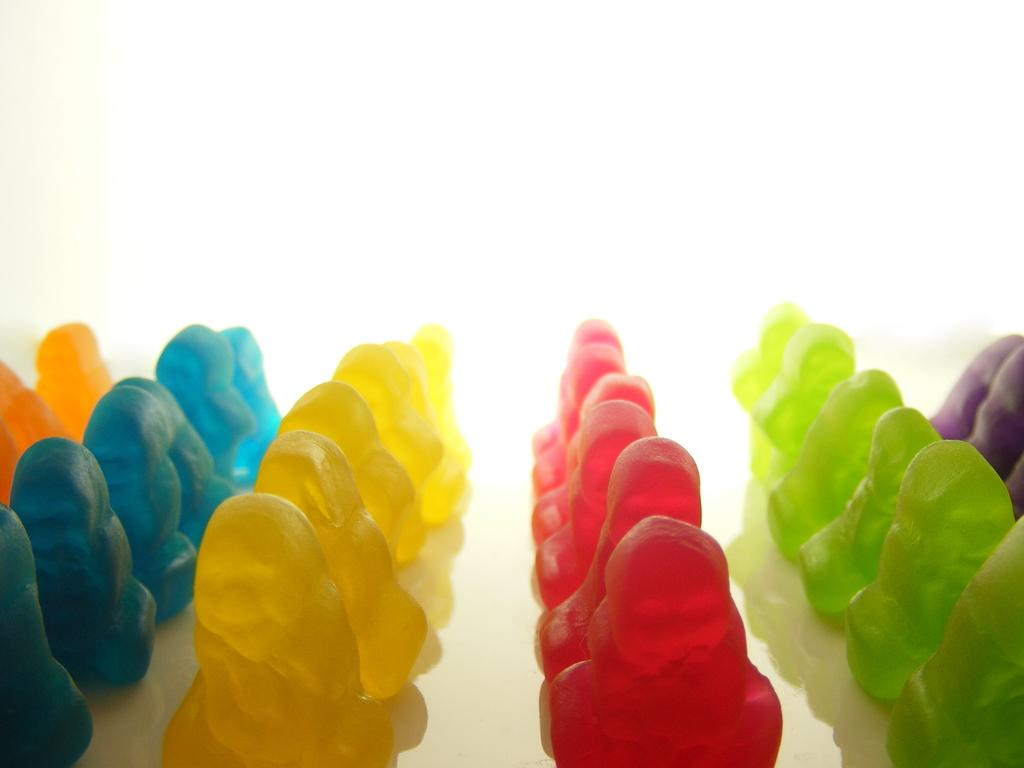What type of substance is present in the image? There is a jelly-like substance in the image. Can you describe the appearance of the jelly-like substance? The jelly-like substance has different colors. What is the color of the background in the image? The background in the image is white. Where is the nearest shop to the lake in the image? There is no shop or lake present in the image; it only features a jelly-like substance with different colors on a white background. 